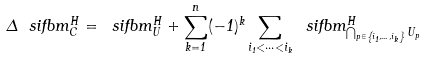<formula> <loc_0><loc_0><loc_500><loc_500>\Delta \ s i f b m ^ { H } _ { C } = \ s i f b m ^ { H } _ { U } + \sum _ { k = 1 } ^ { n } ( - 1 ) ^ { k } \sum _ { i _ { 1 } < \dots < i _ { k } } \ s i f b m ^ { H } _ { \bigcap _ { p \in \left \{ i _ { 1 } , \dots , i _ { k } \right \} } U _ { p } }</formula> 